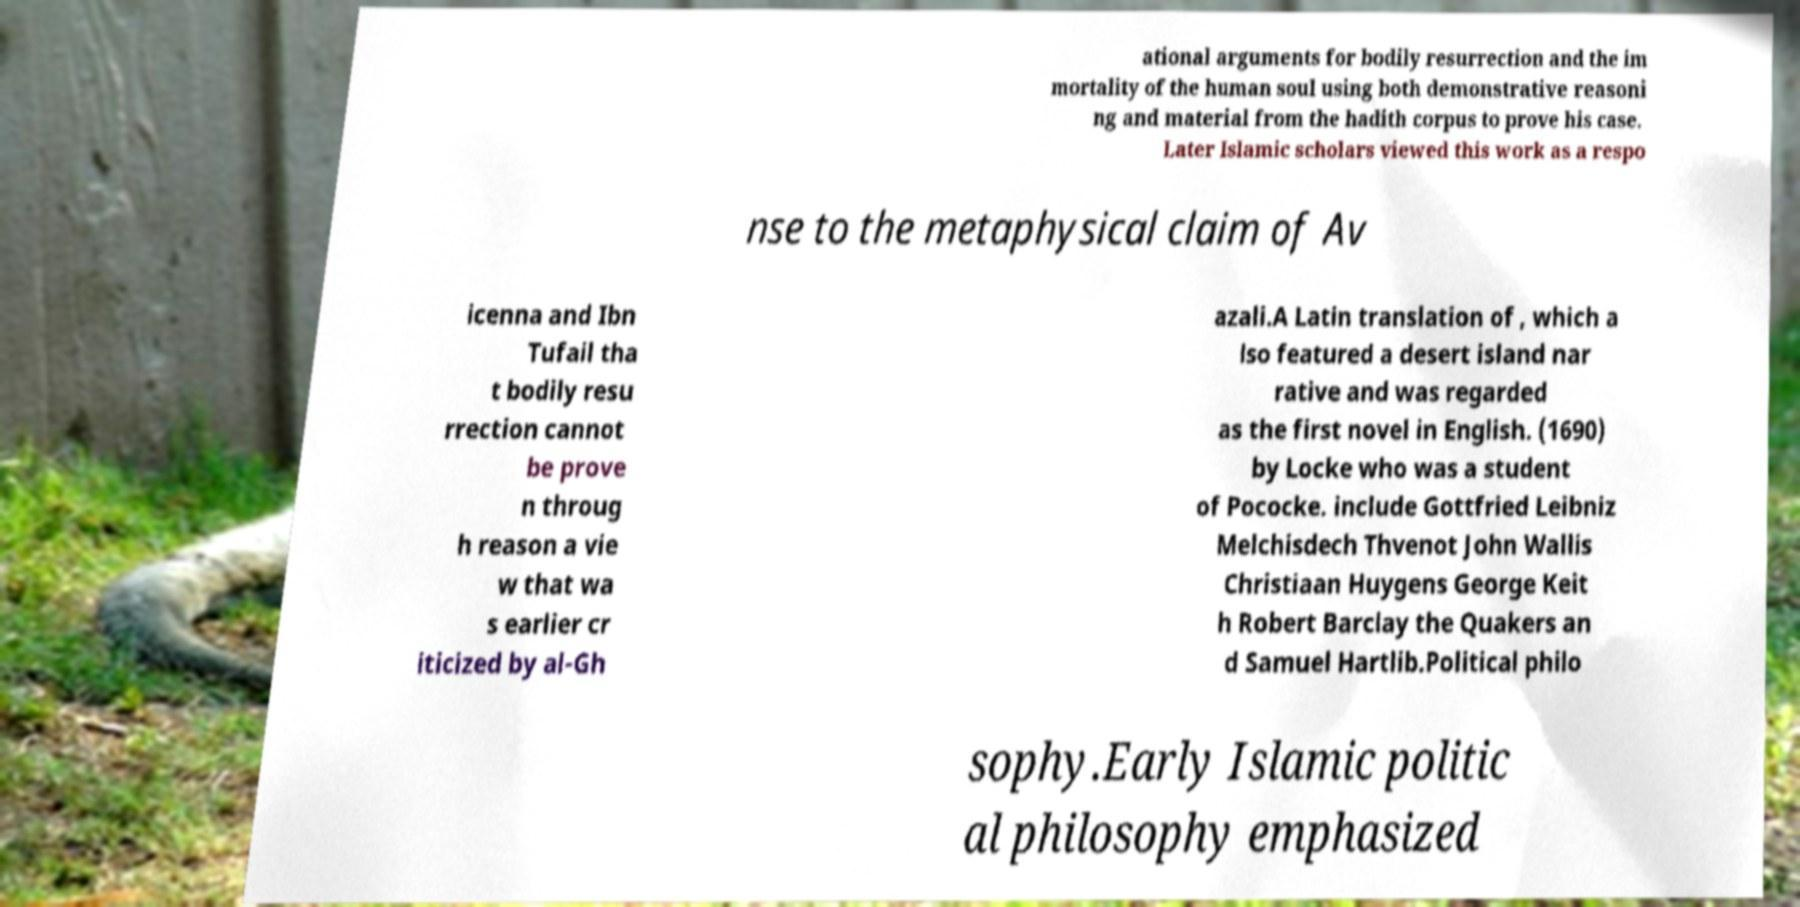There's text embedded in this image that I need extracted. Can you transcribe it verbatim? ational arguments for bodily resurrection and the im mortality of the human soul using both demonstrative reasoni ng and material from the hadith corpus to prove his case. Later Islamic scholars viewed this work as a respo nse to the metaphysical claim of Av icenna and Ibn Tufail tha t bodily resu rrection cannot be prove n throug h reason a vie w that wa s earlier cr iticized by al-Gh azali.A Latin translation of , which a lso featured a desert island nar rative and was regarded as the first novel in English. (1690) by Locke who was a student of Pococke. include Gottfried Leibniz Melchisdech Thvenot John Wallis Christiaan Huygens George Keit h Robert Barclay the Quakers an d Samuel Hartlib.Political philo sophy.Early Islamic politic al philosophy emphasized 